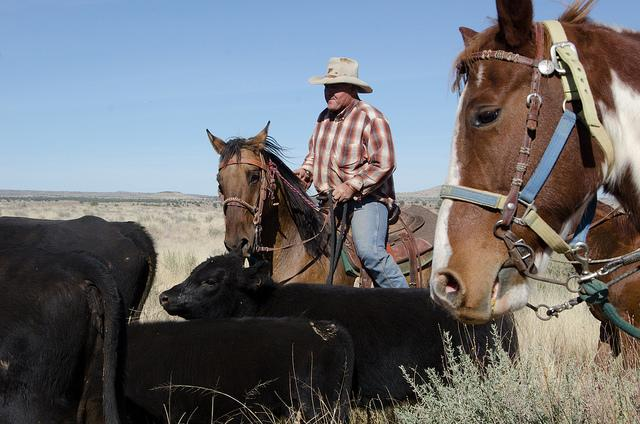How did this man get to this location? horse 